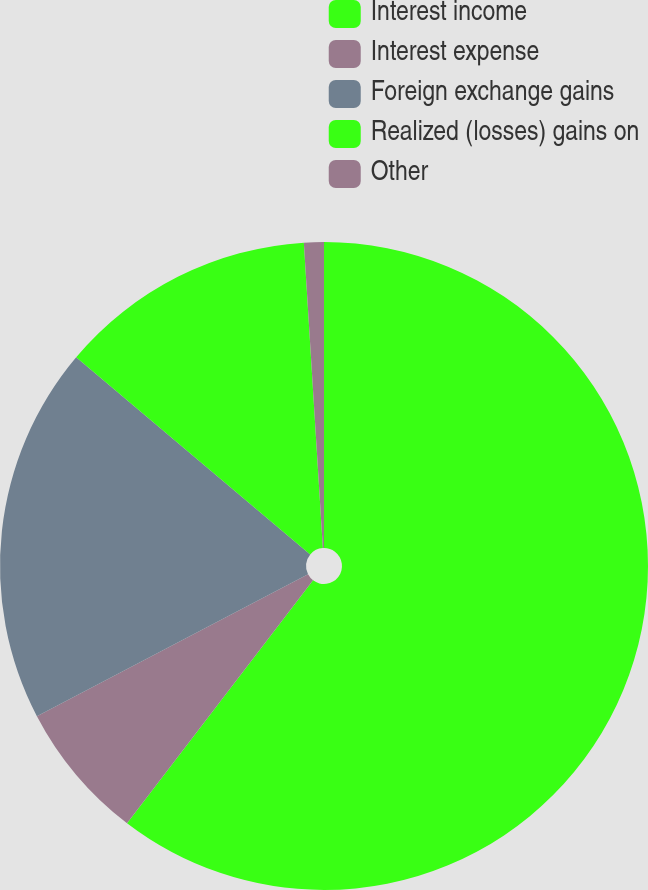Convert chart. <chart><loc_0><loc_0><loc_500><loc_500><pie_chart><fcel>Interest income<fcel>Interest expense<fcel>Foreign exchange gains<fcel>Realized (losses) gains on<fcel>Other<nl><fcel>60.4%<fcel>6.93%<fcel>18.81%<fcel>12.87%<fcel>0.99%<nl></chart> 